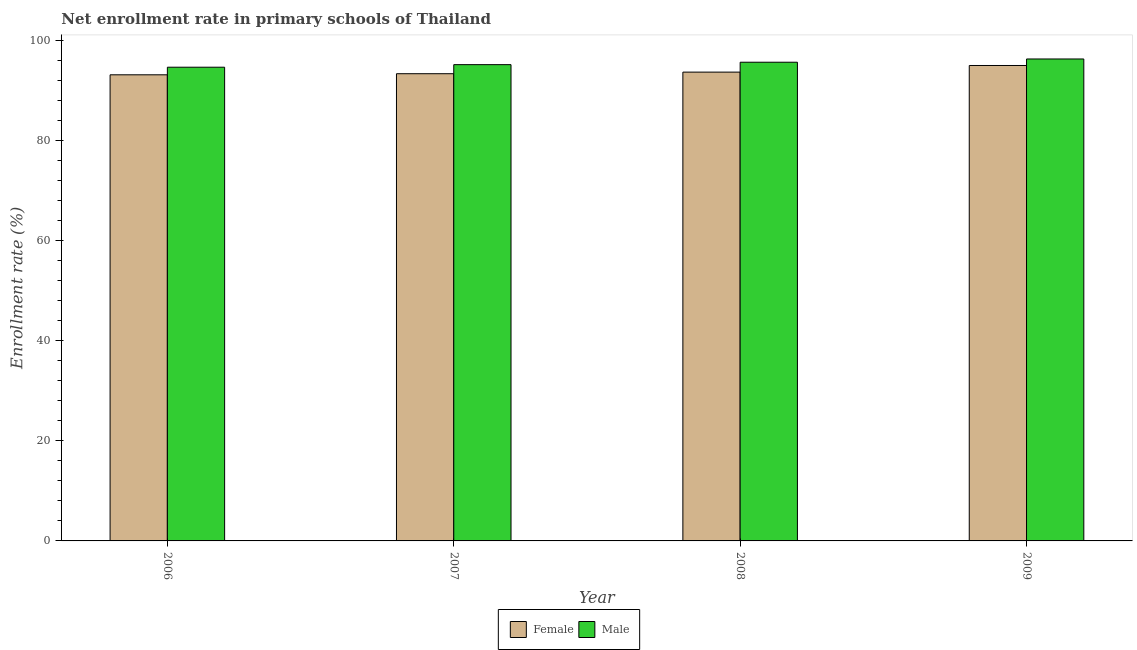How many bars are there on the 1st tick from the left?
Your answer should be compact. 2. How many bars are there on the 4th tick from the right?
Keep it short and to the point. 2. What is the label of the 1st group of bars from the left?
Your response must be concise. 2006. In how many cases, is the number of bars for a given year not equal to the number of legend labels?
Ensure brevity in your answer.  0. What is the enrollment rate of male students in 2007?
Offer a very short reply. 95.11. Across all years, what is the maximum enrollment rate of female students?
Make the answer very short. 94.94. Across all years, what is the minimum enrollment rate of male students?
Make the answer very short. 94.6. What is the total enrollment rate of male students in the graph?
Give a very brief answer. 381.56. What is the difference between the enrollment rate of male students in 2006 and that in 2007?
Provide a succinct answer. -0.51. What is the difference between the enrollment rate of male students in 2006 and the enrollment rate of female students in 2007?
Your answer should be very brief. -0.51. What is the average enrollment rate of male students per year?
Make the answer very short. 95.39. What is the ratio of the enrollment rate of female students in 2006 to that in 2007?
Offer a terse response. 1. Is the enrollment rate of male students in 2006 less than that in 2008?
Give a very brief answer. Yes. What is the difference between the highest and the second highest enrollment rate of female students?
Keep it short and to the point. 1.32. What is the difference between the highest and the lowest enrollment rate of male students?
Your answer should be compact. 1.65. Is the sum of the enrollment rate of female students in 2006 and 2008 greater than the maximum enrollment rate of male students across all years?
Keep it short and to the point. Yes. What does the 1st bar from the left in 2008 represents?
Your answer should be compact. Female. How many bars are there?
Ensure brevity in your answer.  8. What is the difference between two consecutive major ticks on the Y-axis?
Your answer should be compact. 20. Does the graph contain any zero values?
Ensure brevity in your answer.  No. Where does the legend appear in the graph?
Keep it short and to the point. Bottom center. How many legend labels are there?
Offer a terse response. 2. What is the title of the graph?
Give a very brief answer. Net enrollment rate in primary schools of Thailand. What is the label or title of the Y-axis?
Keep it short and to the point. Enrollment rate (%). What is the Enrollment rate (%) of Female in 2006?
Your response must be concise. 93.09. What is the Enrollment rate (%) of Male in 2006?
Provide a succinct answer. 94.6. What is the Enrollment rate (%) in Female in 2007?
Offer a terse response. 93.3. What is the Enrollment rate (%) in Male in 2007?
Ensure brevity in your answer.  95.11. What is the Enrollment rate (%) in Female in 2008?
Offer a terse response. 93.62. What is the Enrollment rate (%) of Male in 2008?
Your response must be concise. 95.6. What is the Enrollment rate (%) of Female in 2009?
Keep it short and to the point. 94.94. What is the Enrollment rate (%) of Male in 2009?
Your answer should be compact. 96.25. Across all years, what is the maximum Enrollment rate (%) in Female?
Your answer should be compact. 94.94. Across all years, what is the maximum Enrollment rate (%) of Male?
Make the answer very short. 96.25. Across all years, what is the minimum Enrollment rate (%) of Female?
Make the answer very short. 93.09. Across all years, what is the minimum Enrollment rate (%) in Male?
Offer a terse response. 94.6. What is the total Enrollment rate (%) in Female in the graph?
Your answer should be very brief. 374.96. What is the total Enrollment rate (%) of Male in the graph?
Your answer should be very brief. 381.56. What is the difference between the Enrollment rate (%) in Female in 2006 and that in 2007?
Offer a very short reply. -0.22. What is the difference between the Enrollment rate (%) of Male in 2006 and that in 2007?
Provide a succinct answer. -0.51. What is the difference between the Enrollment rate (%) of Female in 2006 and that in 2008?
Offer a terse response. -0.54. What is the difference between the Enrollment rate (%) in Male in 2006 and that in 2008?
Your answer should be compact. -1. What is the difference between the Enrollment rate (%) in Female in 2006 and that in 2009?
Ensure brevity in your answer.  -1.86. What is the difference between the Enrollment rate (%) of Male in 2006 and that in 2009?
Provide a short and direct response. -1.65. What is the difference between the Enrollment rate (%) in Female in 2007 and that in 2008?
Give a very brief answer. -0.32. What is the difference between the Enrollment rate (%) in Male in 2007 and that in 2008?
Your answer should be very brief. -0.49. What is the difference between the Enrollment rate (%) in Female in 2007 and that in 2009?
Your answer should be very brief. -1.64. What is the difference between the Enrollment rate (%) of Male in 2007 and that in 2009?
Offer a very short reply. -1.13. What is the difference between the Enrollment rate (%) of Female in 2008 and that in 2009?
Provide a succinct answer. -1.32. What is the difference between the Enrollment rate (%) of Male in 2008 and that in 2009?
Provide a short and direct response. -0.65. What is the difference between the Enrollment rate (%) in Female in 2006 and the Enrollment rate (%) in Male in 2007?
Keep it short and to the point. -2.03. What is the difference between the Enrollment rate (%) of Female in 2006 and the Enrollment rate (%) of Male in 2008?
Offer a very short reply. -2.51. What is the difference between the Enrollment rate (%) of Female in 2006 and the Enrollment rate (%) of Male in 2009?
Ensure brevity in your answer.  -3.16. What is the difference between the Enrollment rate (%) of Female in 2007 and the Enrollment rate (%) of Male in 2008?
Give a very brief answer. -2.3. What is the difference between the Enrollment rate (%) in Female in 2007 and the Enrollment rate (%) in Male in 2009?
Your answer should be compact. -2.94. What is the difference between the Enrollment rate (%) in Female in 2008 and the Enrollment rate (%) in Male in 2009?
Provide a succinct answer. -2.62. What is the average Enrollment rate (%) of Female per year?
Keep it short and to the point. 93.74. What is the average Enrollment rate (%) of Male per year?
Your response must be concise. 95.39. In the year 2006, what is the difference between the Enrollment rate (%) of Female and Enrollment rate (%) of Male?
Your answer should be very brief. -1.51. In the year 2007, what is the difference between the Enrollment rate (%) in Female and Enrollment rate (%) in Male?
Keep it short and to the point. -1.81. In the year 2008, what is the difference between the Enrollment rate (%) in Female and Enrollment rate (%) in Male?
Your answer should be compact. -1.98. In the year 2009, what is the difference between the Enrollment rate (%) of Female and Enrollment rate (%) of Male?
Give a very brief answer. -1.3. What is the ratio of the Enrollment rate (%) in Male in 2006 to that in 2007?
Keep it short and to the point. 0.99. What is the ratio of the Enrollment rate (%) of Female in 2006 to that in 2009?
Make the answer very short. 0.98. What is the ratio of the Enrollment rate (%) in Male in 2006 to that in 2009?
Keep it short and to the point. 0.98. What is the ratio of the Enrollment rate (%) of Male in 2007 to that in 2008?
Make the answer very short. 0.99. What is the ratio of the Enrollment rate (%) in Female in 2007 to that in 2009?
Ensure brevity in your answer.  0.98. What is the ratio of the Enrollment rate (%) of Male in 2007 to that in 2009?
Provide a succinct answer. 0.99. What is the ratio of the Enrollment rate (%) in Female in 2008 to that in 2009?
Offer a very short reply. 0.99. What is the ratio of the Enrollment rate (%) of Male in 2008 to that in 2009?
Give a very brief answer. 0.99. What is the difference between the highest and the second highest Enrollment rate (%) of Female?
Your response must be concise. 1.32. What is the difference between the highest and the second highest Enrollment rate (%) in Male?
Your answer should be compact. 0.65. What is the difference between the highest and the lowest Enrollment rate (%) in Female?
Provide a short and direct response. 1.86. What is the difference between the highest and the lowest Enrollment rate (%) of Male?
Ensure brevity in your answer.  1.65. 